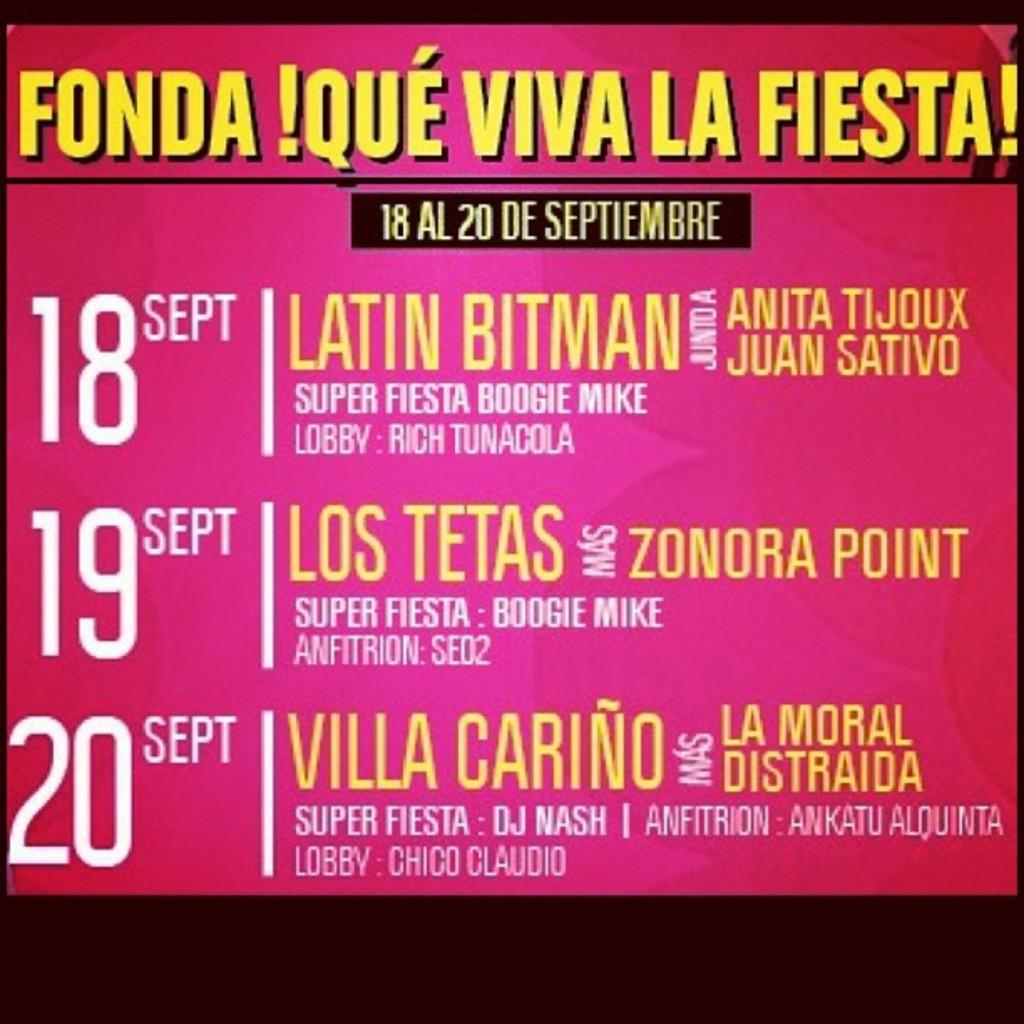What is present in the image that contains information or a message? There is a banner in the image that contains text. Can you describe the banner in the image? The banner in the image contains text, but we cannot determine the specific message or design from the provided facts. What color is the seashore in the image? There is no seashore present in the image; it only contains a banner with text. 